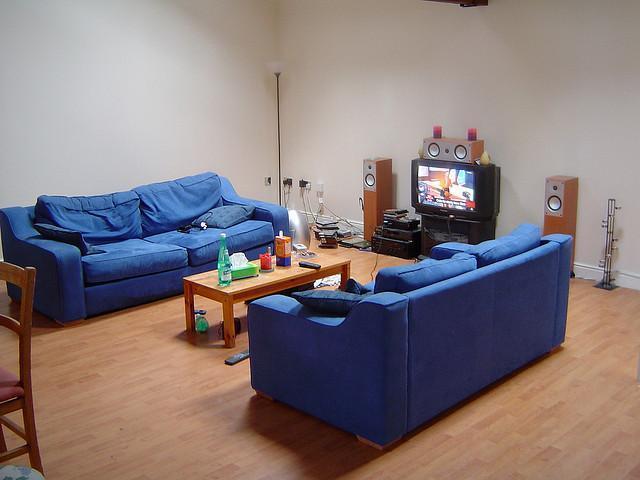How many couches are there?
Give a very brief answer. 2. 